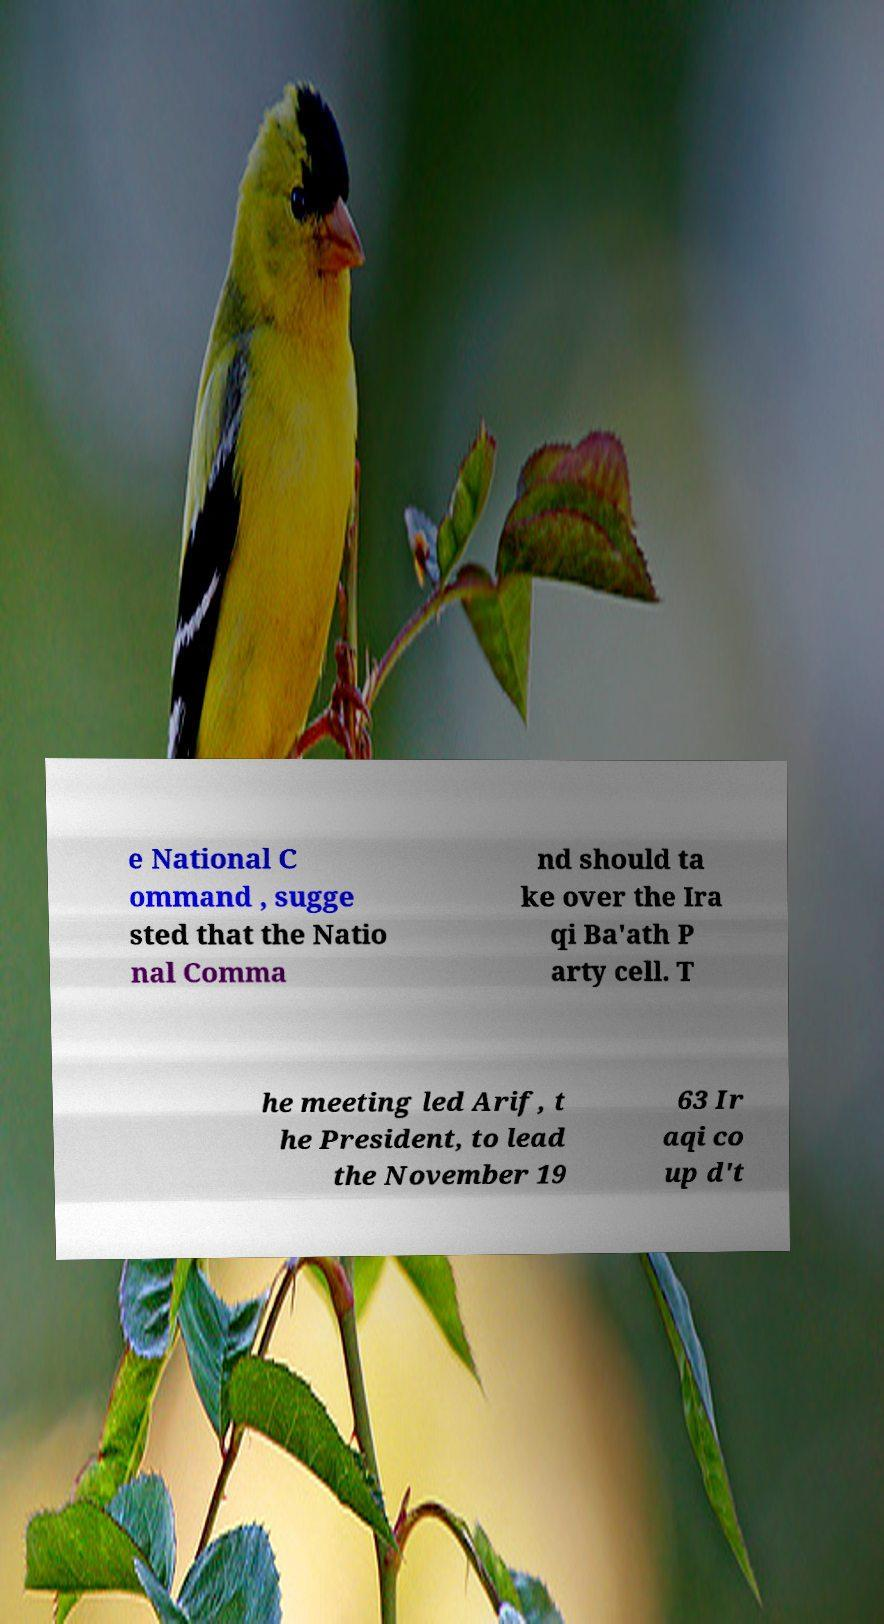What messages or text are displayed in this image? I need them in a readable, typed format. e National C ommand , sugge sted that the Natio nal Comma nd should ta ke over the Ira qi Ba'ath P arty cell. T he meeting led Arif, t he President, to lead the November 19 63 Ir aqi co up d't 